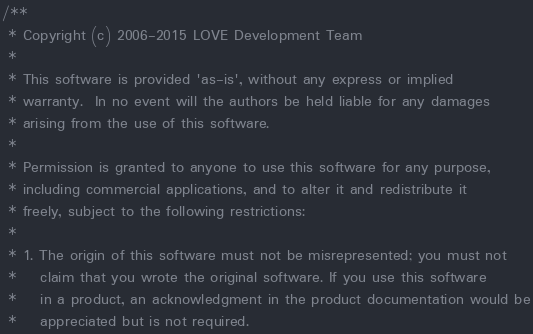<code> <loc_0><loc_0><loc_500><loc_500><_C++_>/**
 * Copyright (c) 2006-2015 LOVE Development Team
 *
 * This software is provided 'as-is', without any express or implied
 * warranty.  In no event will the authors be held liable for any damages
 * arising from the use of this software.
 *
 * Permission is granted to anyone to use this software for any purpose,
 * including commercial applications, and to alter it and redistribute it
 * freely, subject to the following restrictions:
 *
 * 1. The origin of this software must not be misrepresented; you must not
 *    claim that you wrote the original software. If you use this software
 *    in a product, an acknowledgment in the product documentation would be
 *    appreciated but is not required.</code> 